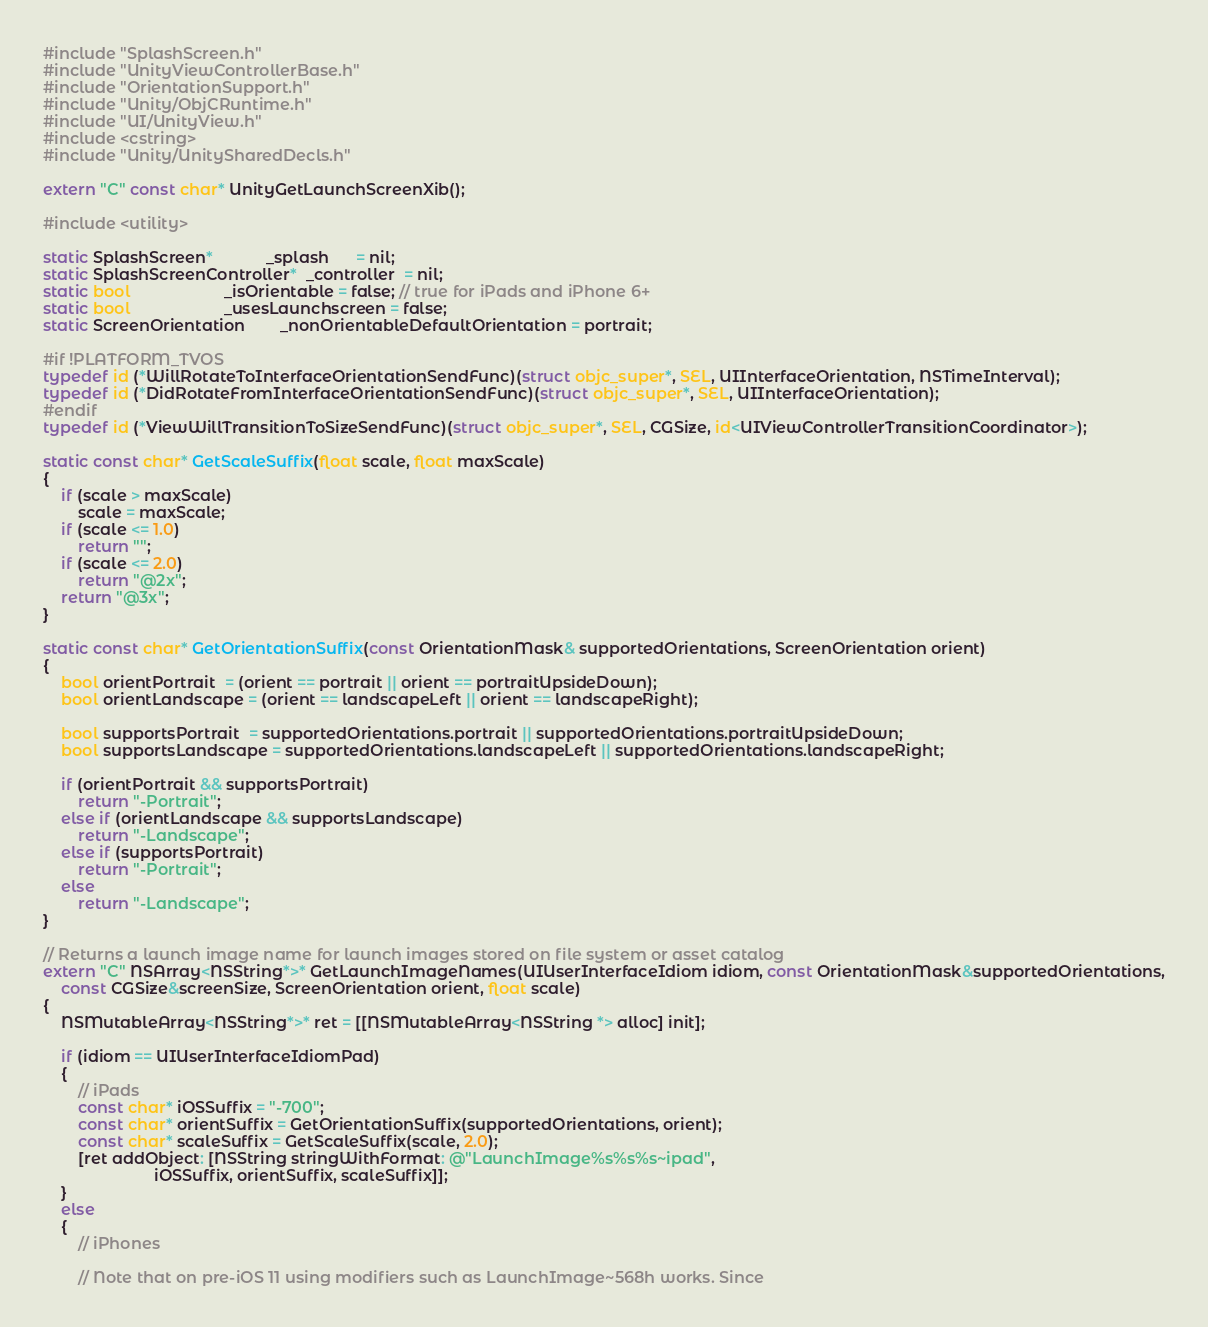<code> <loc_0><loc_0><loc_500><loc_500><_ObjectiveC_>#include "SplashScreen.h"
#include "UnityViewControllerBase.h"
#include "OrientationSupport.h"
#include "Unity/ObjCRuntime.h"
#include "UI/UnityView.h"
#include <cstring>
#include "Unity/UnitySharedDecls.h"

extern "C" const char* UnityGetLaunchScreenXib();

#include <utility>

static SplashScreen*            _splash      = nil;
static SplashScreenController*  _controller  = nil;
static bool                     _isOrientable = false; // true for iPads and iPhone 6+
static bool                     _usesLaunchscreen = false;
static ScreenOrientation        _nonOrientableDefaultOrientation = portrait;

#if !PLATFORM_TVOS
typedef id (*WillRotateToInterfaceOrientationSendFunc)(struct objc_super*, SEL, UIInterfaceOrientation, NSTimeInterval);
typedef id (*DidRotateFromInterfaceOrientationSendFunc)(struct objc_super*, SEL, UIInterfaceOrientation);
#endif
typedef id (*ViewWillTransitionToSizeSendFunc)(struct objc_super*, SEL, CGSize, id<UIViewControllerTransitionCoordinator>);

static const char* GetScaleSuffix(float scale, float maxScale)
{
    if (scale > maxScale)
        scale = maxScale;
    if (scale <= 1.0)
        return "";
    if (scale <= 2.0)
        return "@2x";
    return "@3x";
}

static const char* GetOrientationSuffix(const OrientationMask& supportedOrientations, ScreenOrientation orient)
{
    bool orientPortrait  = (orient == portrait || orient == portraitUpsideDown);
    bool orientLandscape = (orient == landscapeLeft || orient == landscapeRight);

    bool supportsPortrait  = supportedOrientations.portrait || supportedOrientations.portraitUpsideDown;
    bool supportsLandscape = supportedOrientations.landscapeLeft || supportedOrientations.landscapeRight;

    if (orientPortrait && supportsPortrait)
        return "-Portrait";
    else if (orientLandscape && supportsLandscape)
        return "-Landscape";
    else if (supportsPortrait)
        return "-Portrait";
    else
        return "-Landscape";
}

// Returns a launch image name for launch images stored on file system or asset catalog
extern "C" NSArray<NSString*>* GetLaunchImageNames(UIUserInterfaceIdiom idiom, const OrientationMask&supportedOrientations,
    const CGSize&screenSize, ScreenOrientation orient, float scale)
{
    NSMutableArray<NSString*>* ret = [[NSMutableArray<NSString *> alloc] init];

    if (idiom == UIUserInterfaceIdiomPad)
    {
        // iPads
        const char* iOSSuffix = "-700";
        const char* orientSuffix = GetOrientationSuffix(supportedOrientations, orient);
        const char* scaleSuffix = GetScaleSuffix(scale, 2.0);
        [ret addObject: [NSString stringWithFormat: @"LaunchImage%s%s%s~ipad",
                         iOSSuffix, orientSuffix, scaleSuffix]];
    }
    else
    {
        // iPhones

        // Note that on pre-iOS 11 using modifiers such as LaunchImage~568h works. Since</code> 